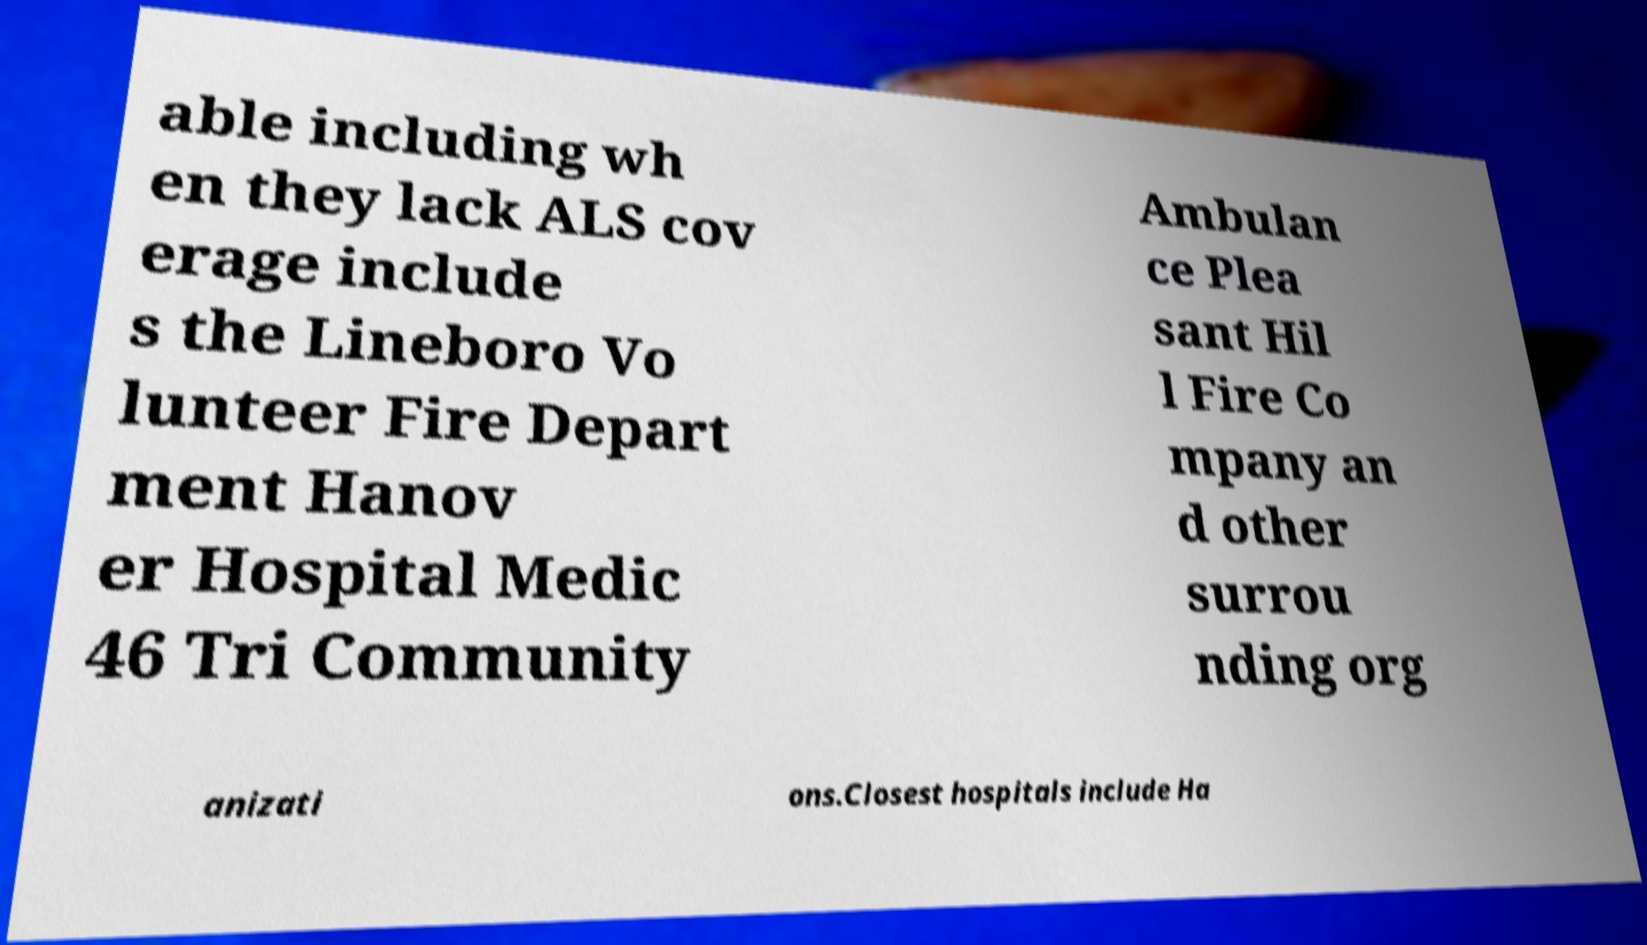Can you accurately transcribe the text from the provided image for me? able including wh en they lack ALS cov erage include s the Lineboro Vo lunteer Fire Depart ment Hanov er Hospital Medic 46 Tri Community Ambulan ce Plea sant Hil l Fire Co mpany an d other surrou nding org anizati ons.Closest hospitals include Ha 